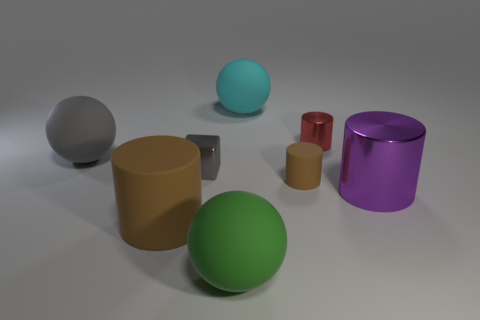How does the lighting affect the appearance of the objects? The lighting in the image creates soft shadows and subtle highlights on the objects, giving a three-dimensional effect and accentuating their shapes and textures. Could you describe the texture of the objects based on the lighting? Certainly. The lighting suggests that the surfaces of the objects are smooth and matte, with minimal reflection, which indicates that they might have a somewhat satiny finish. 